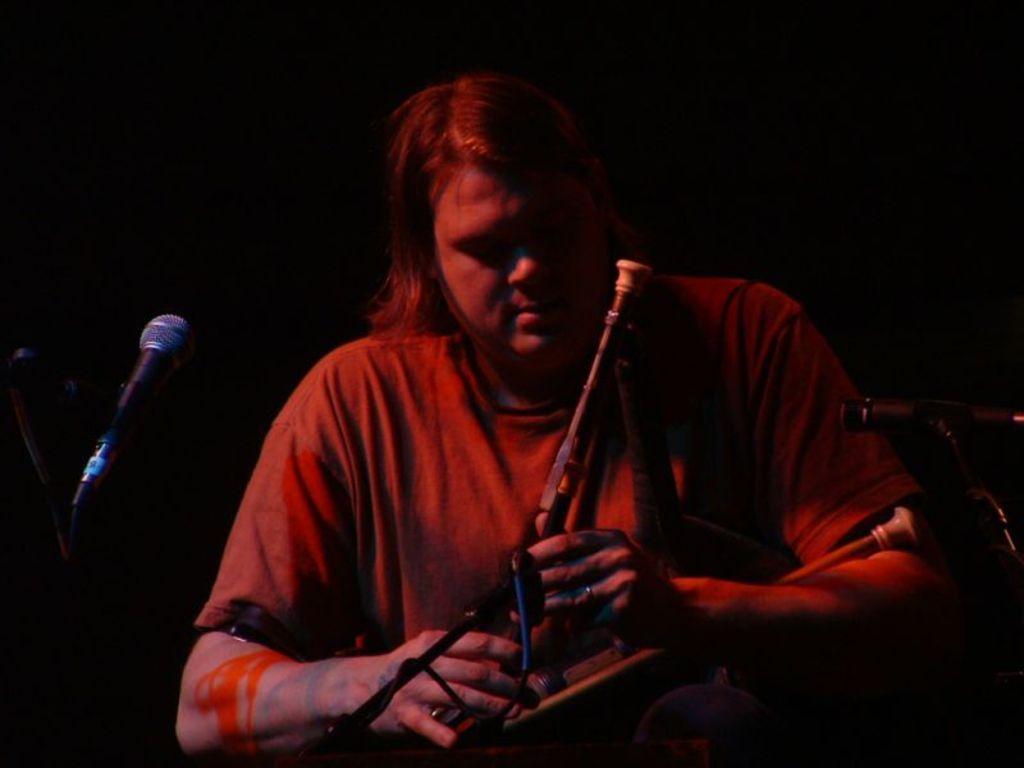Describe this image in one or two sentences. In this picture we can see a person holding a musical instrument in his hand. There is a stand on the right side. We can see a mic on the left side. 